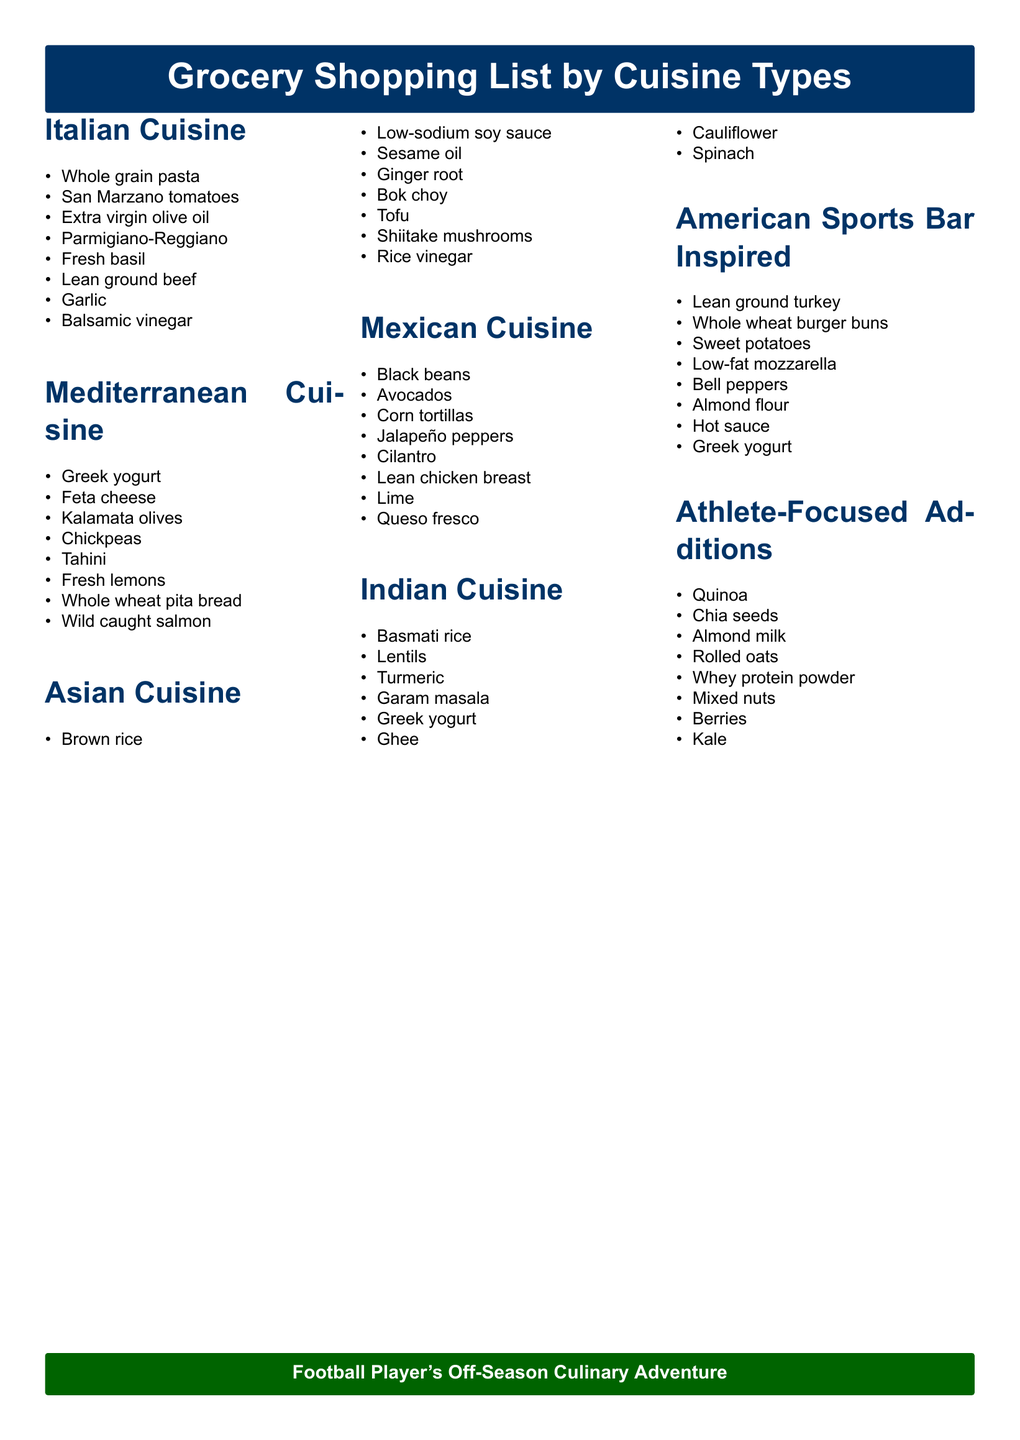What are the main ingredients in Italian cuisine? Italian cuisine includes specific items like whole grain pasta, San Marzano tomatoes, and extra virgin olive oil, as listed in the document.
Answer: Whole grain pasta, San Marzano tomatoes, extra virgin olive oil How many cuisines are included in the grocery list? The document lists seven distinct cuisines, which can be counted in the provided sections.
Answer: Seven What is a key protein source in Indian cuisine? The document mentions lentils as a significant protein source in the Indian cuisine section.
Answer: Lentils Which item is included in both Mediterranean and Indian cuisines? Greek yogurt appears in both the Mediterranean and Indian cuisine sections of the document as a listed item.
Answer: Greek yogurt What is the purpose of the Athlete-Focused Additions section? The section is dedicated to items that enhance nutritional intake for athletes, focusing on balanced and complete protein sources.
Answer: Enhance nutritional intake What type of milk is suggested in the Athlete-Focused Additions? The document specifies almond milk as one of the items in the Athlete-Focused Additions section.
Answer: Almond milk Which cuisine features ingredients like black beans and avocados? The document identifies these items as part of the Mexican cuisine section, explicitly listing them.
Answer: Mexican cuisine How is Greek yogurt used in the American Sports Bar Inspired section? Greek yogurt serves as a substitute for sour cream in healthier versions of typical sports bar food, according to the document.
Answer: As a sour cream substitute 